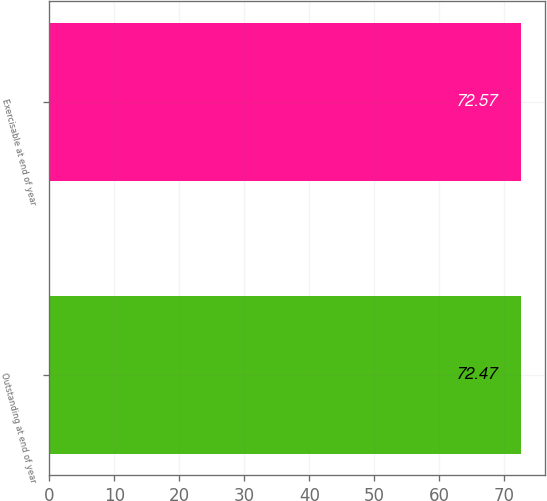Convert chart to OTSL. <chart><loc_0><loc_0><loc_500><loc_500><bar_chart><fcel>Outstanding at end of year<fcel>Exercisable at end of year<nl><fcel>72.47<fcel>72.57<nl></chart> 